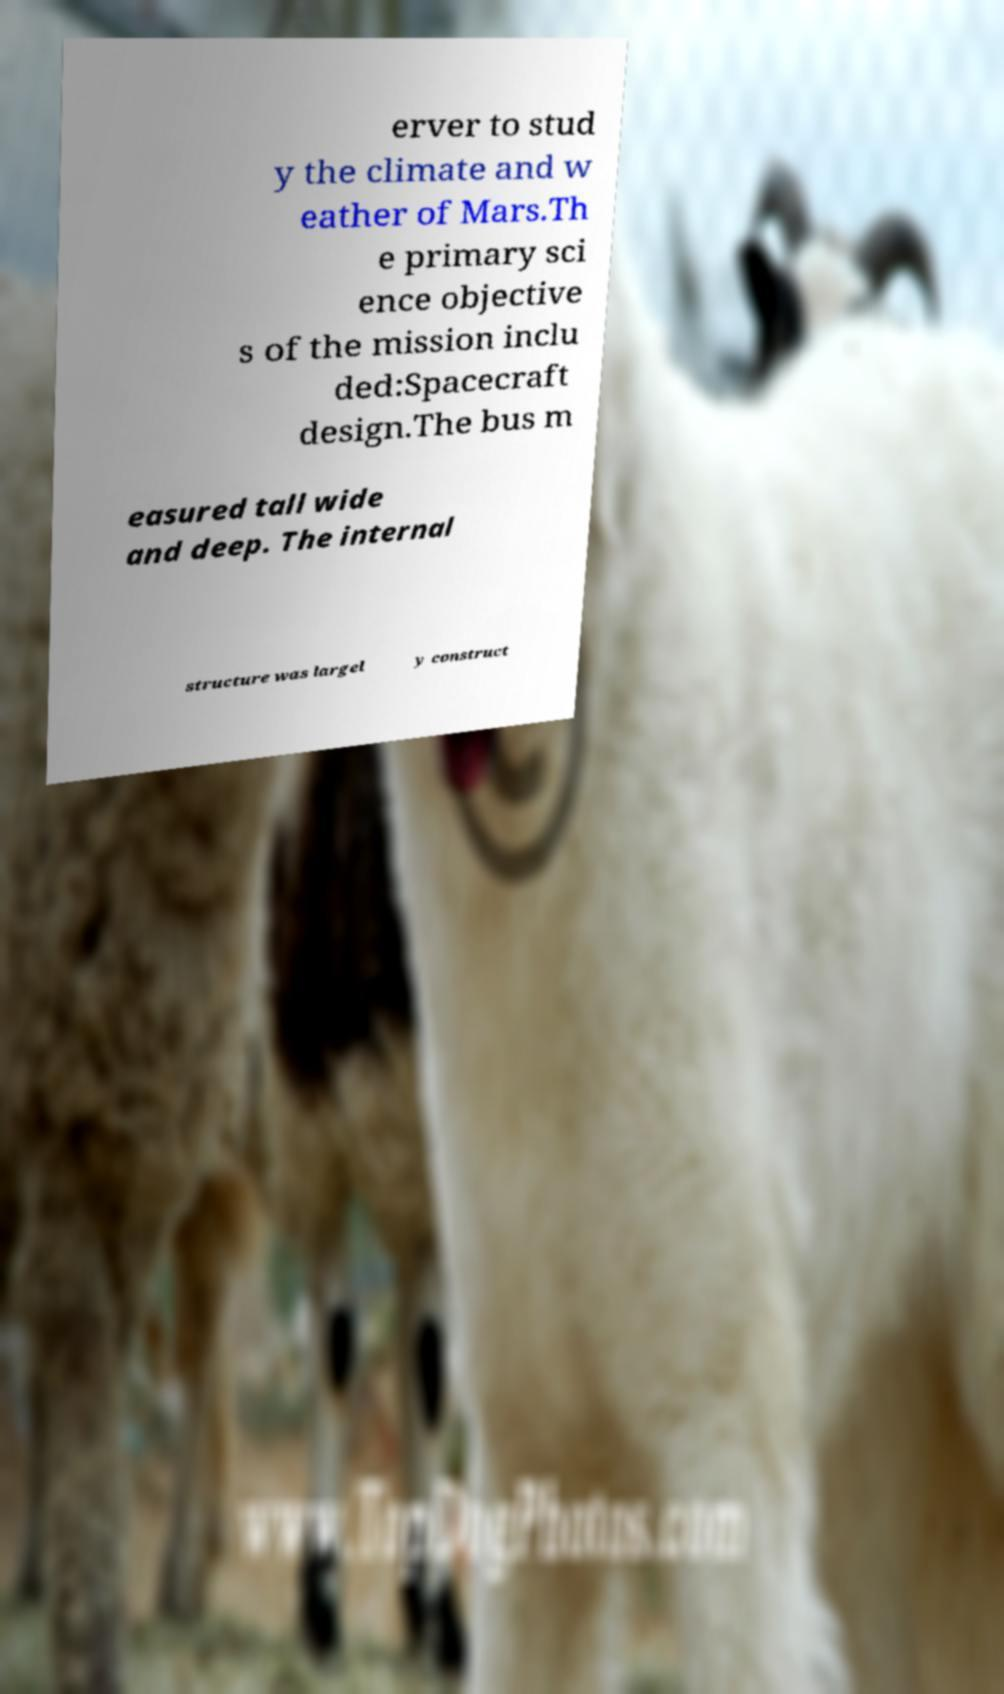Could you assist in decoding the text presented in this image and type it out clearly? erver to stud y the climate and w eather of Mars.Th e primary sci ence objective s of the mission inclu ded:Spacecraft design.The bus m easured tall wide and deep. The internal structure was largel y construct 